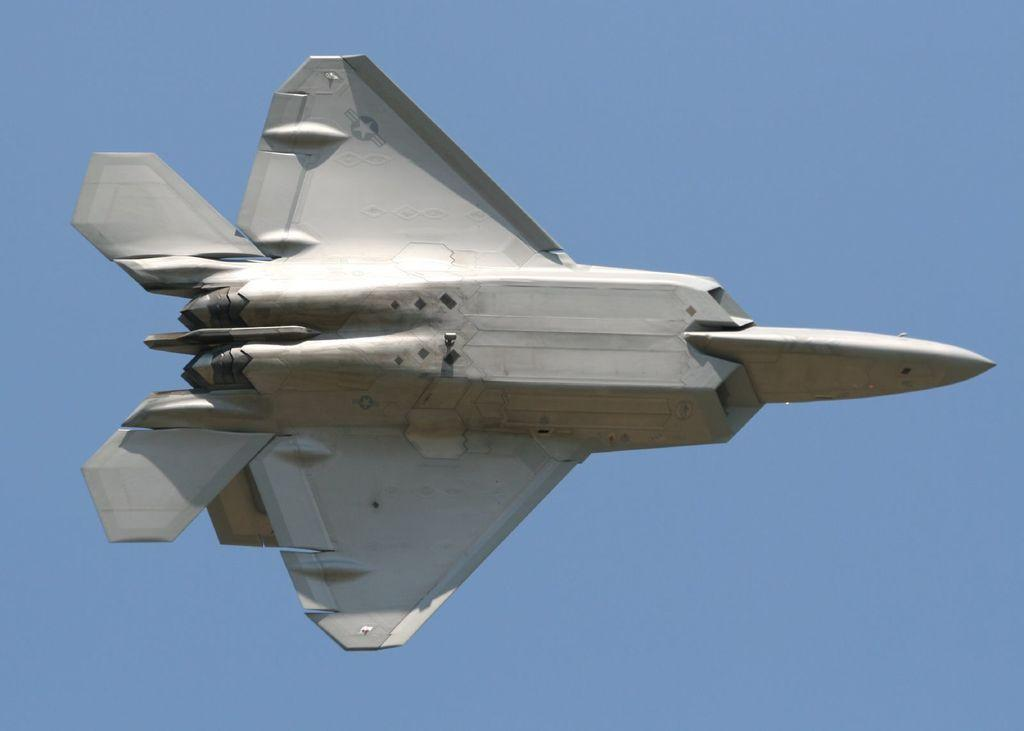What is the main subject of the picture? The main subject of the picture is an aircraft. What is the color of the aircraft? The aircraft is white in color. What is the aircraft doing in the picture? The aircraft is flying in the air. What can be seen in the background of the image? There is a sky visible in the background of the image. How many kittens are sitting inside the aircraft frame in the image? There are no kittens or frames present in the image; it features an aircraft flying in the sky. 